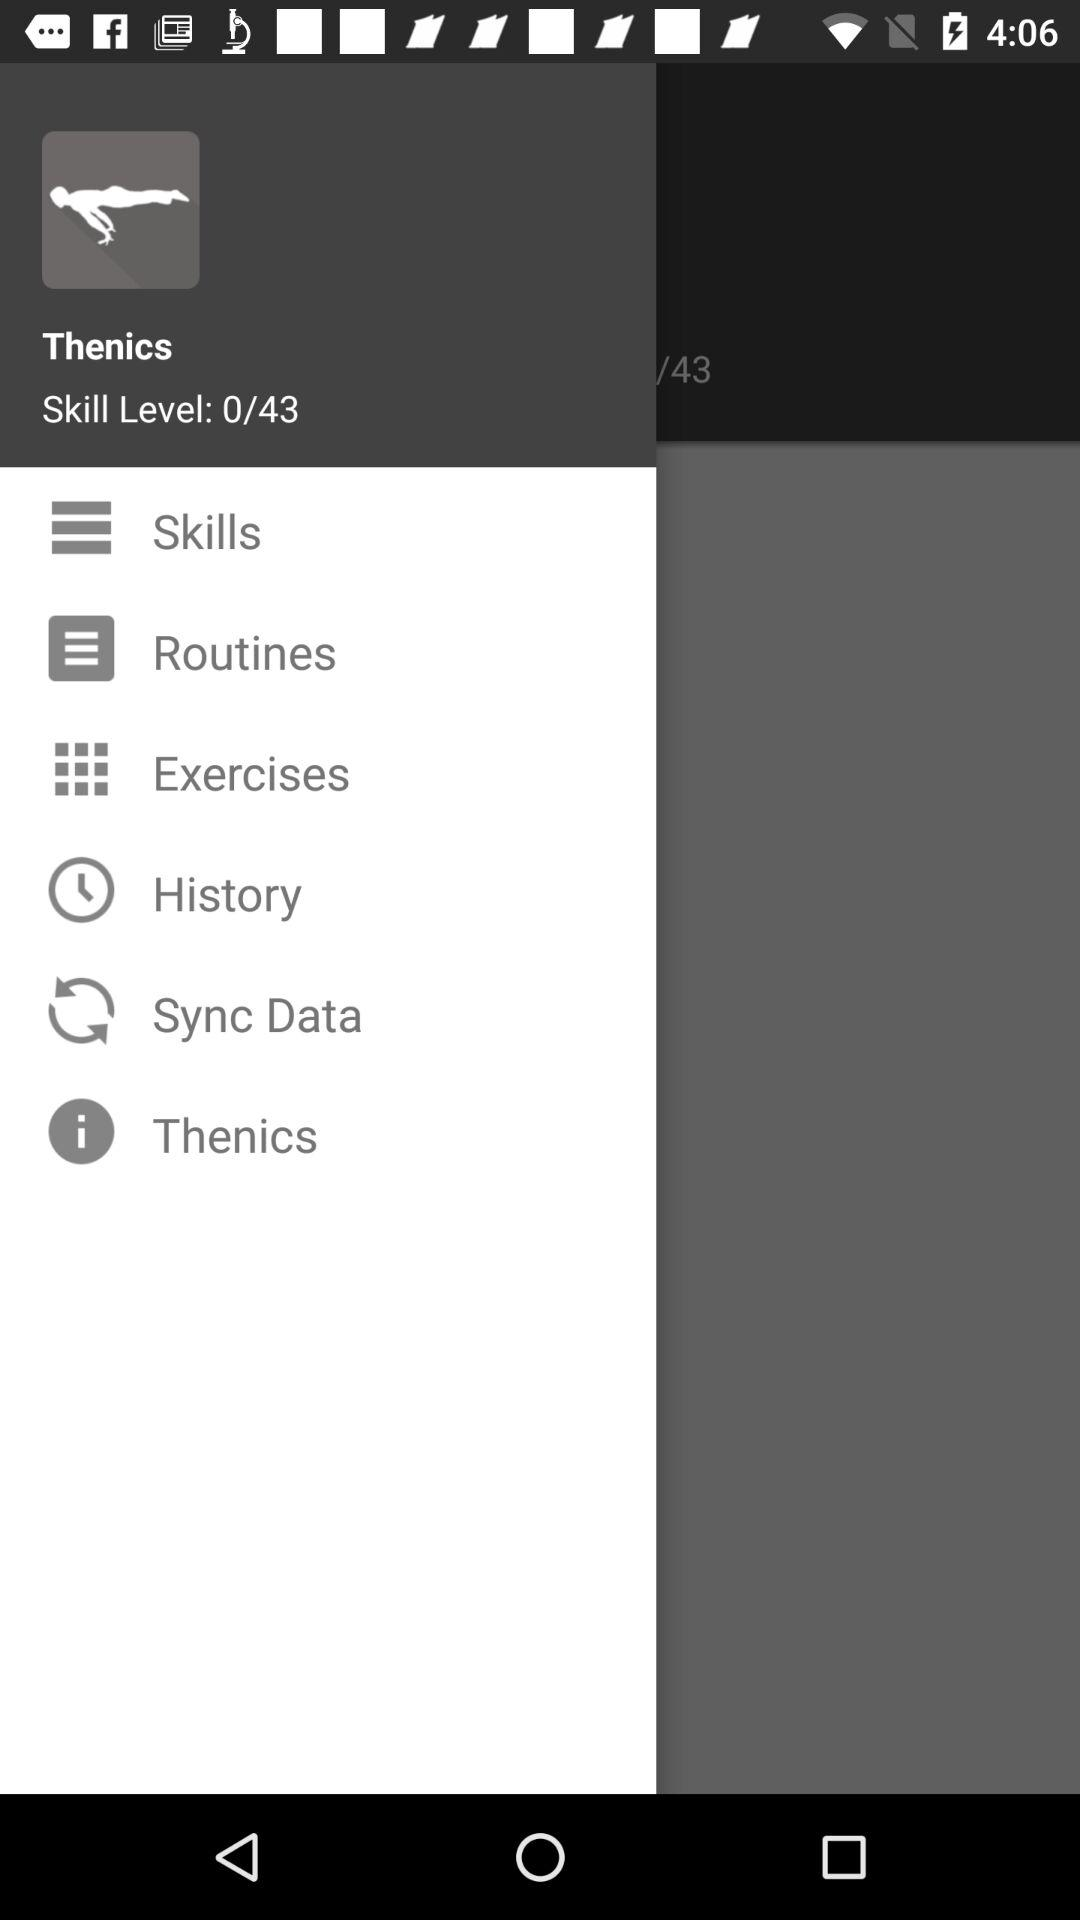How many more skills do I have to complete to reach level 43?
Answer the question using a single word or phrase. 43 